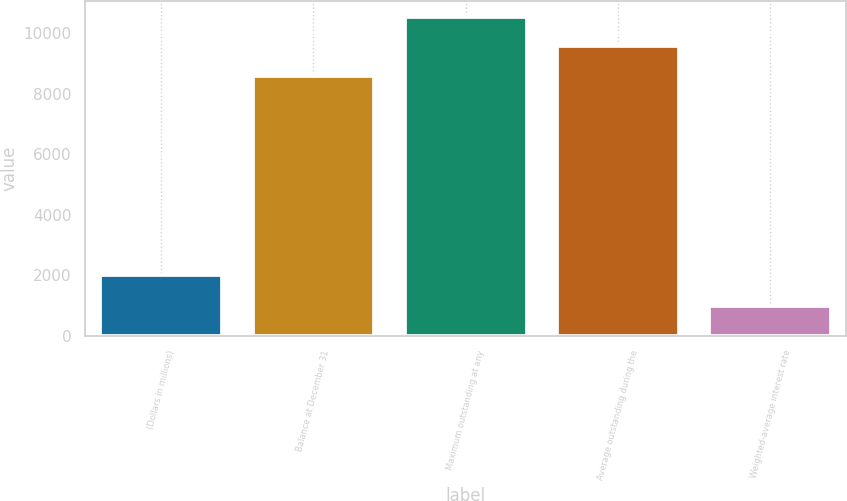<chart> <loc_0><loc_0><loc_500><loc_500><bar_chart><fcel>(Dollars in millions)<fcel>Balance at December 31<fcel>Maximum outstanding at any<fcel>Average outstanding during the<fcel>Weighted-average interest rate<nl><fcel>2011<fcel>8572<fcel>10542.6<fcel>9557.3<fcel>985.34<nl></chart> 